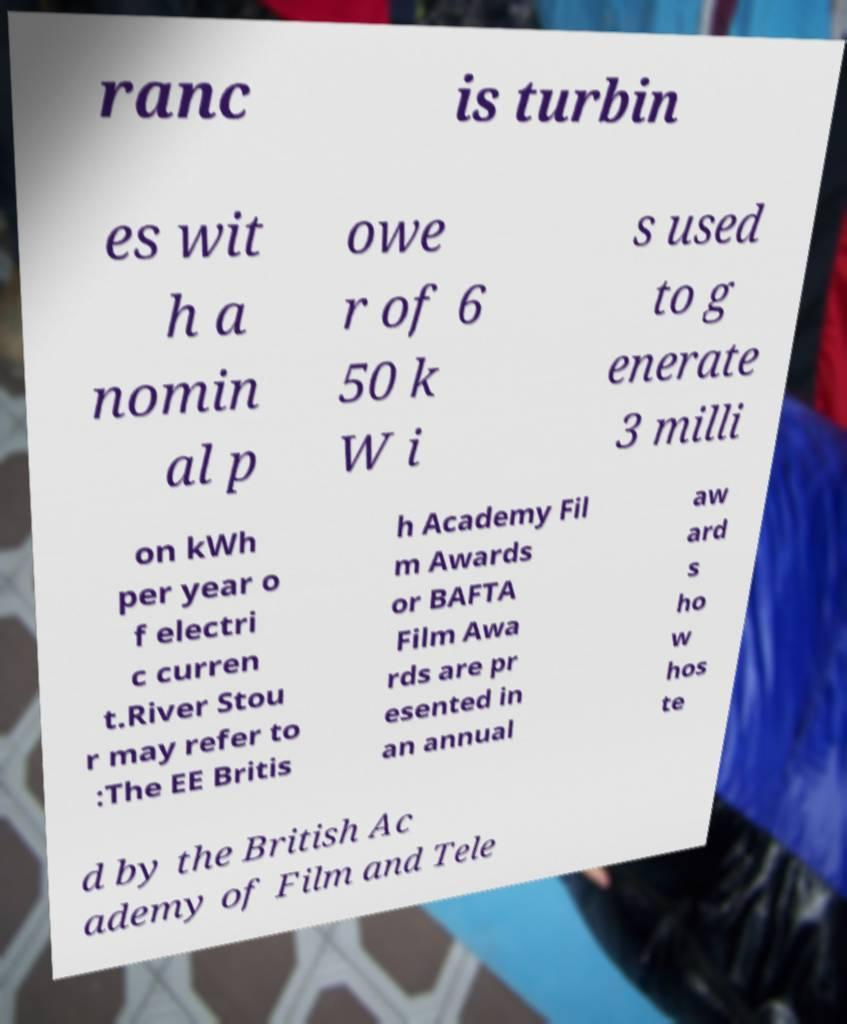What messages or text are displayed in this image? I need them in a readable, typed format. ranc is turbin es wit h a nomin al p owe r of 6 50 k W i s used to g enerate 3 milli on kWh per year o f electri c curren t.River Stou r may refer to :The EE Britis h Academy Fil m Awards or BAFTA Film Awa rds are pr esented in an annual aw ard s ho w hos te d by the British Ac ademy of Film and Tele 